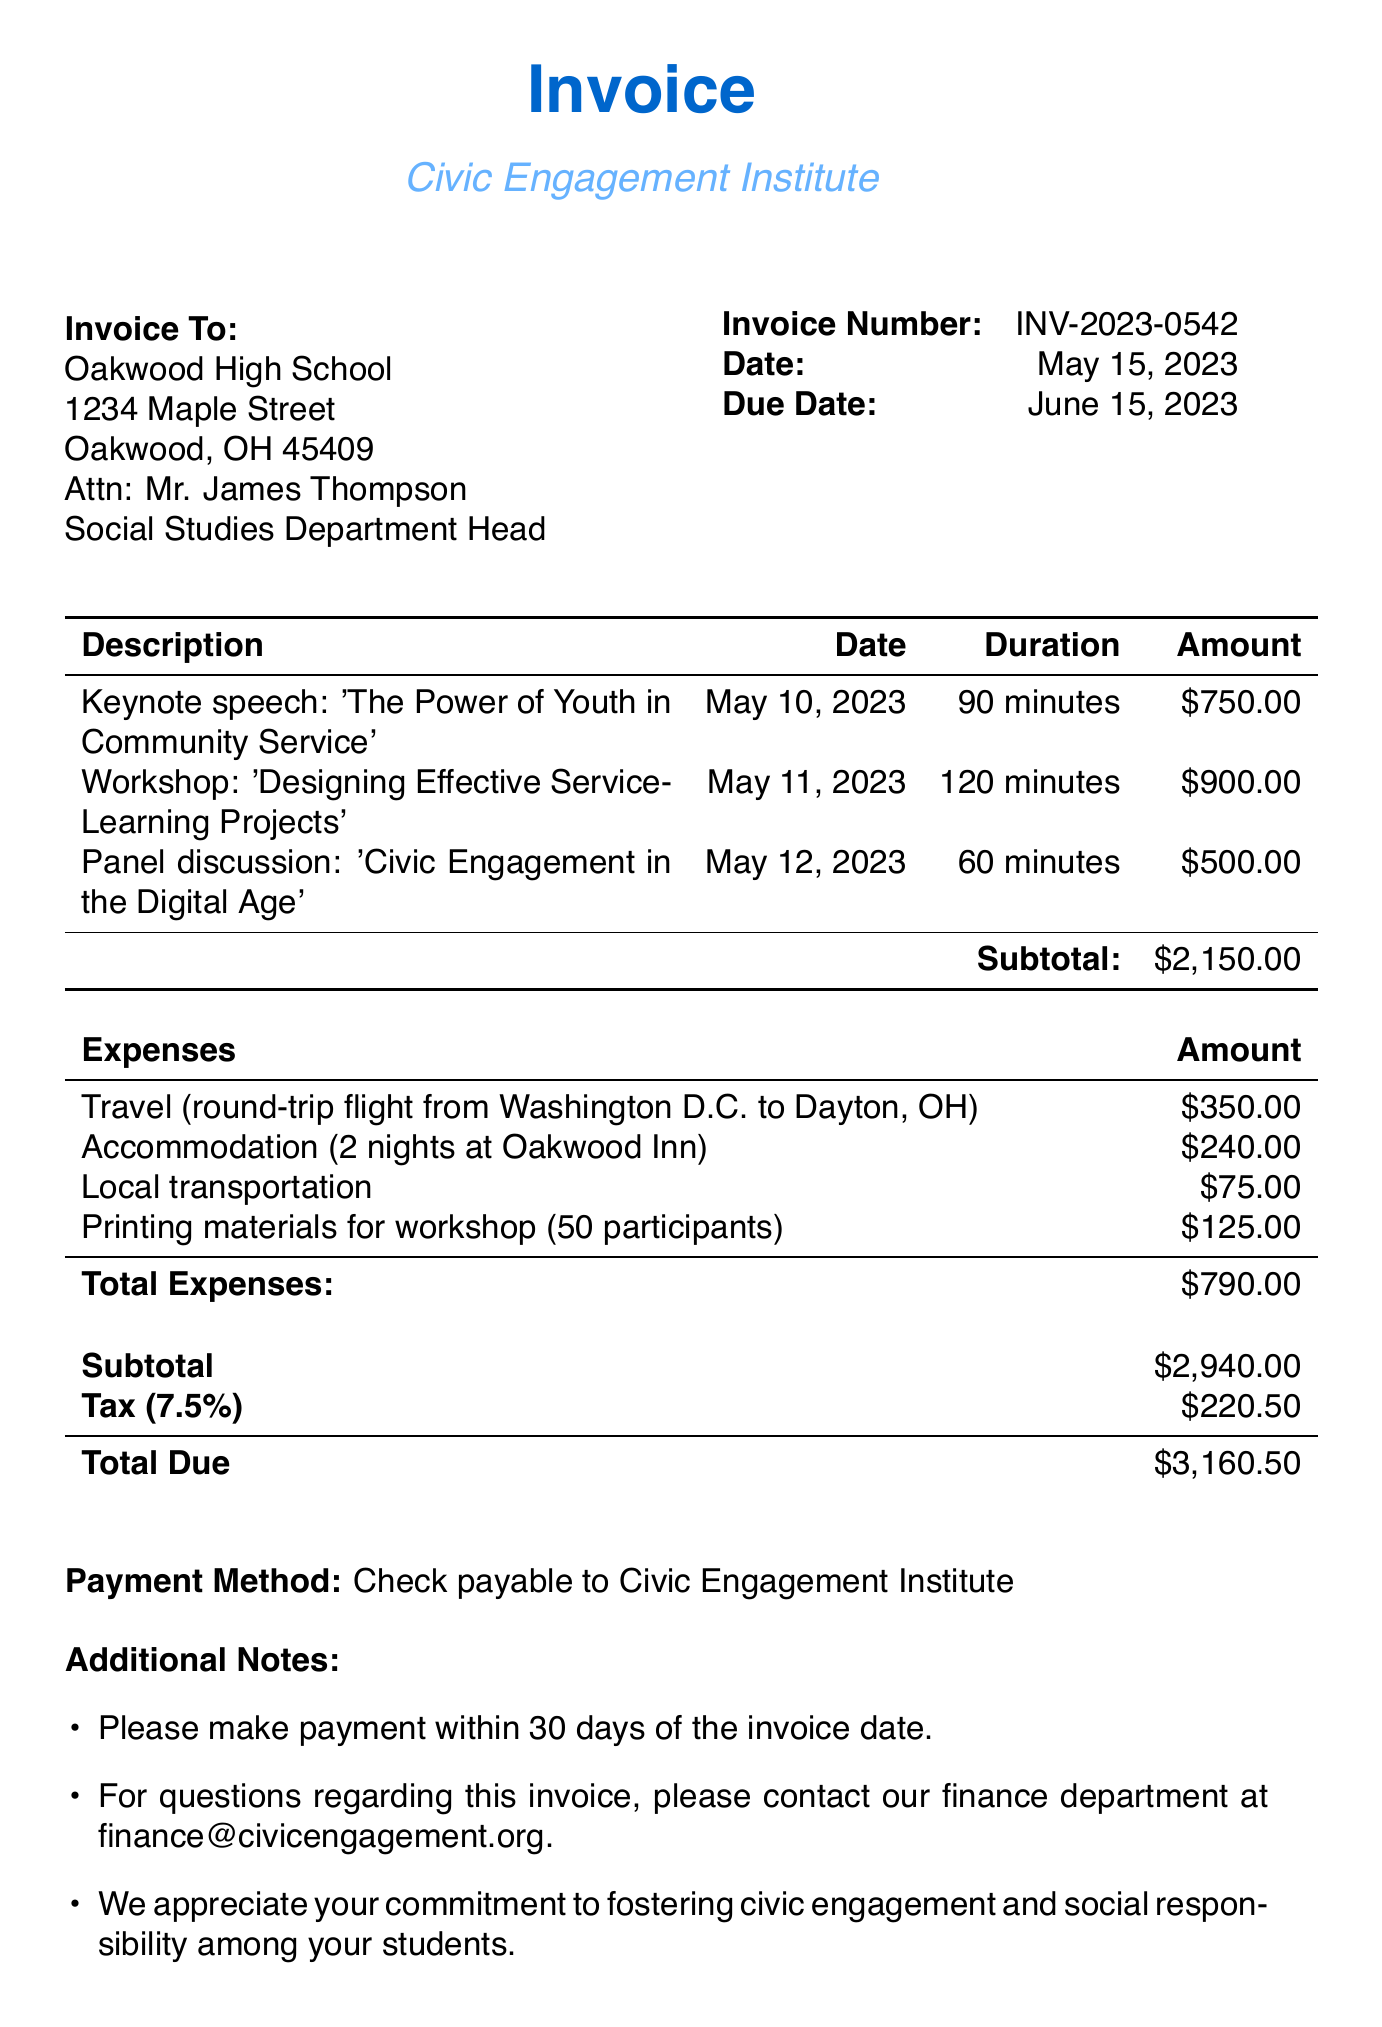What is the invoice number? The invoice number is clearly stated in the document as a unique identifier, which is often needed for reference.
Answer: INV-2023-0542 Who is the guest speaker? The document mentions the guest speaker's name, which is essential for understanding who provided the services.
Answer: Dr. Amanda Rodriguez What is the date of the keynote speech? The date is specified for each service, helping to establish a timeline of events.
Answer: May 10, 2023 How much is the fee for the workshop? The fee for each service is provided, which helps the client understand the cost of the services rendered.
Answer: $900.00 What is the total amount due? The total due is the final figure that combines all costs and is important for payment purposes.
Answer: $3,160.50 What is the tax rate applied on the subtotal? The tax rate is mentioned in the document, which is important for calculating the final amount due.
Answer: 7.5% How many nights did the guest speaker stay? The accommodation details provide insights into the arrangements made for the speaker, crucial for expense tracking.
Answer: 2 nights Which organization is the guest speaker associated with? The organization is specified, which can be relevant for credibility and recognition of the speaker's background.
Answer: Civic Engagement Institute What is the payment method specified? The payment method is outlined in the invoice, which informs the client how to proceed with payment.
Answer: Check payable to Civic Engagement Institute What is included in the additional notes? The additional notes section provides important payment and contact information, summarizing key details.
Answer: Payment within 30 days 